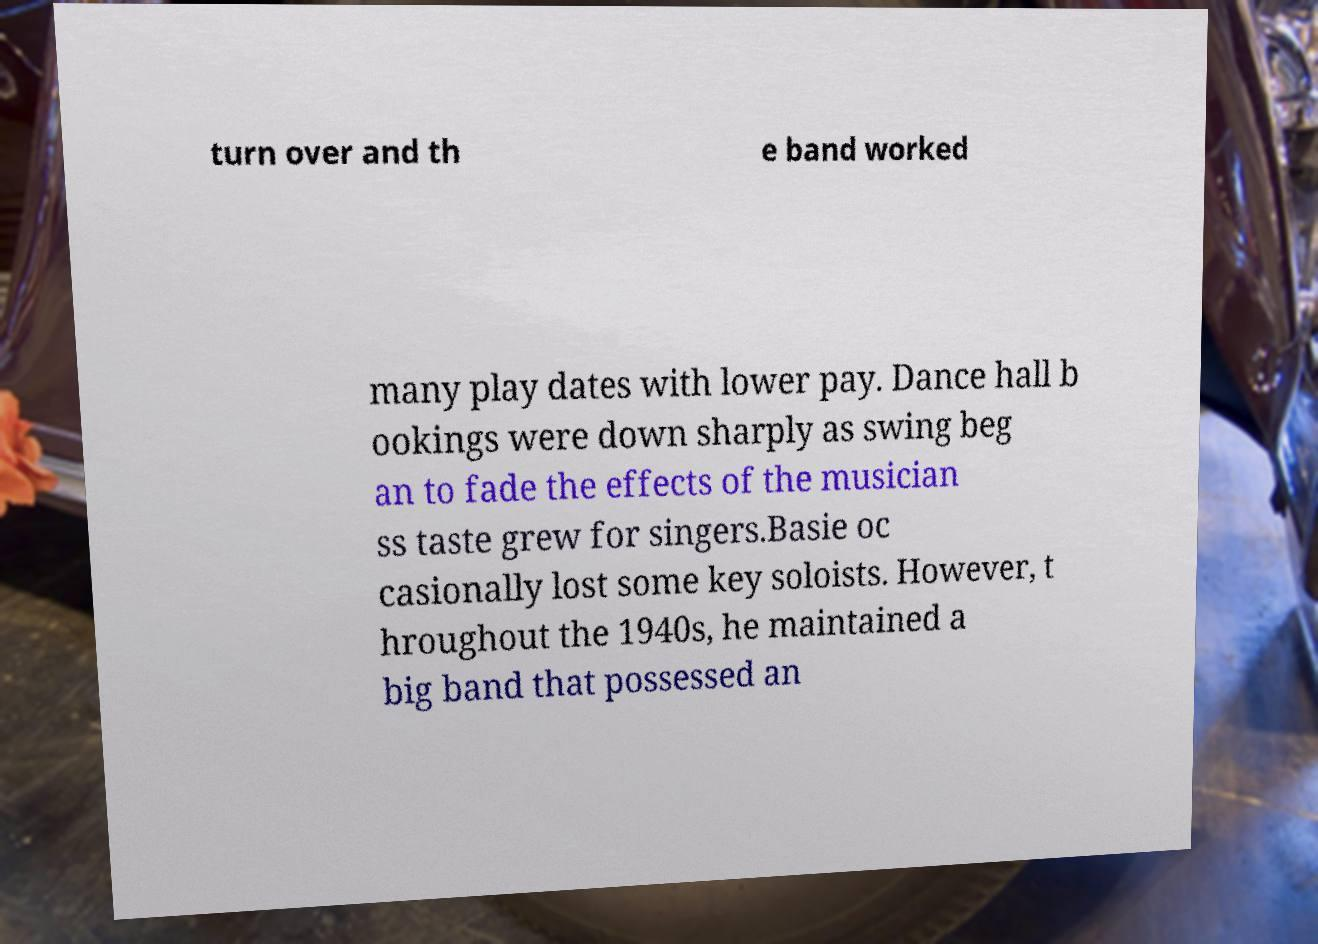For documentation purposes, I need the text within this image transcribed. Could you provide that? turn over and th e band worked many play dates with lower pay. Dance hall b ookings were down sharply as swing beg an to fade the effects of the musician ss taste grew for singers.Basie oc casionally lost some key soloists. However, t hroughout the 1940s, he maintained a big band that possessed an 